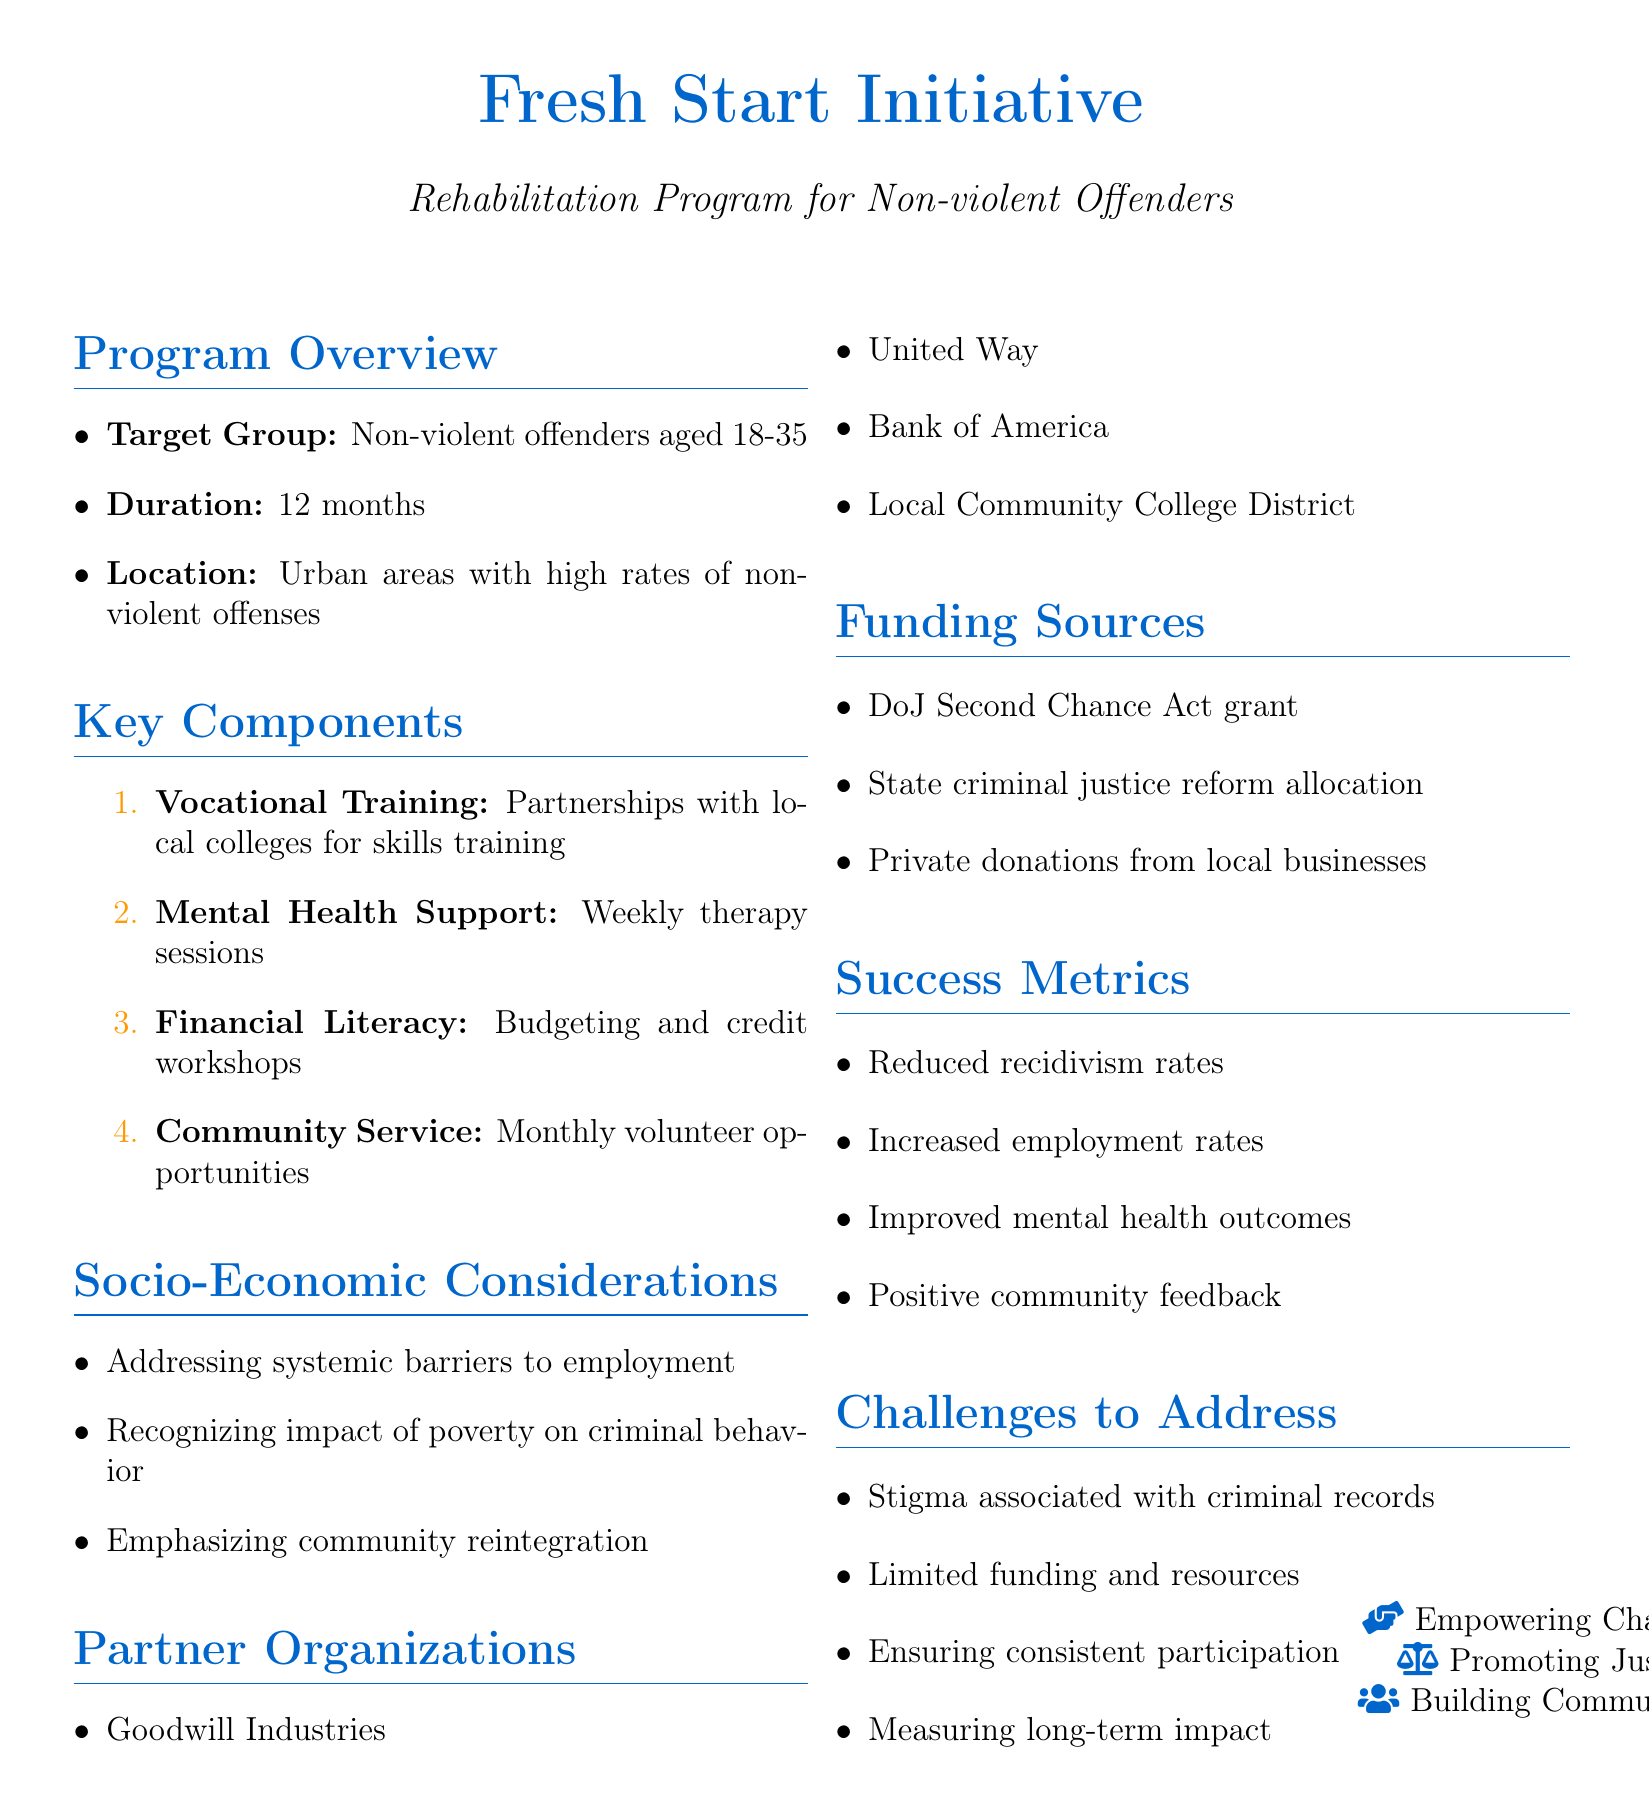What is the program name? The program name is specified at the beginning of the document.
Answer: Fresh Start Initiative Who is the target group? The target group is identified in the program overview section.
Answer: Non-violent offenders aged 18-35 What is the duration of the program? The duration is mentioned alongside the program overview details.
Answer: 12 months What is one of the partner organizations? Partner organizations are listed in a specific section of the document.
Answer: Goodwill Industries What is one of the success metrics? Success metrics are enumerated within a dedicated section of the document.
Answer: Reduced recidivism rates What challenges does the program address? The challenges are outlined in a specific section of the document.
Answer: Stigma associated with criminal records How many key components are listed? The number of key components can be counted from the enumerated list in the document.
Answer: Four What is the long-term vision of the program? The long-term vision is specified towards the end of the document.
Answer: Expand the program statewide and create a model for national implementation What types of professionals are part of the staff composition? The staff composition includes different types of professionals as listed in the document.
Answer: Licensed social workers 